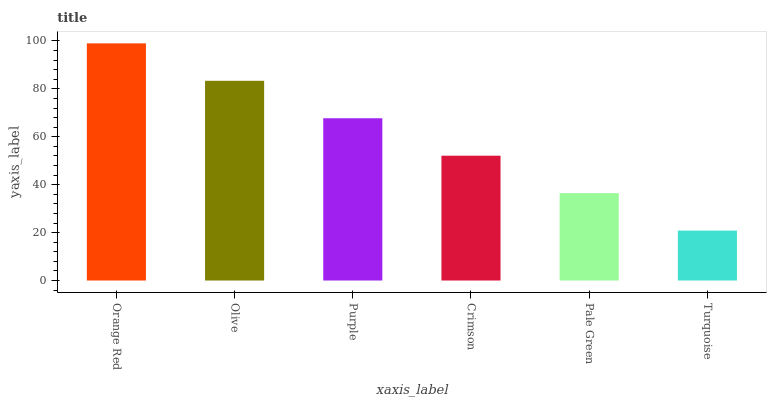Is Turquoise the minimum?
Answer yes or no. Yes. Is Orange Red the maximum?
Answer yes or no. Yes. Is Olive the minimum?
Answer yes or no. No. Is Olive the maximum?
Answer yes or no. No. Is Orange Red greater than Olive?
Answer yes or no. Yes. Is Olive less than Orange Red?
Answer yes or no. Yes. Is Olive greater than Orange Red?
Answer yes or no. No. Is Orange Red less than Olive?
Answer yes or no. No. Is Purple the high median?
Answer yes or no. Yes. Is Crimson the low median?
Answer yes or no. Yes. Is Crimson the high median?
Answer yes or no. No. Is Olive the low median?
Answer yes or no. No. 